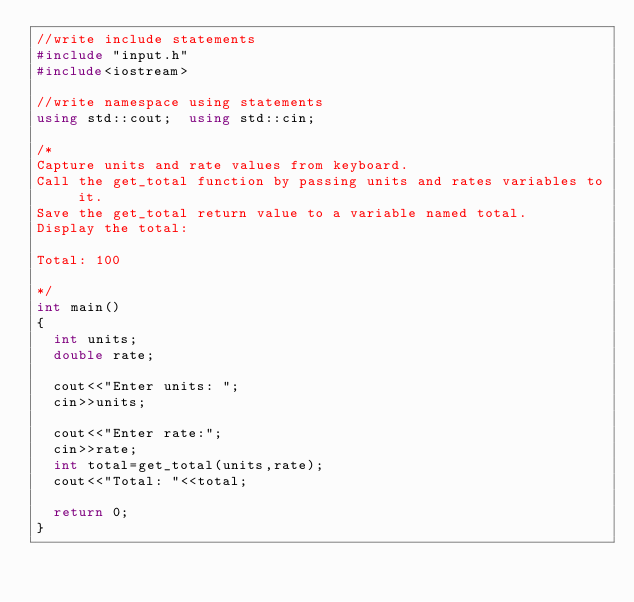<code> <loc_0><loc_0><loc_500><loc_500><_C++_>//write include statements
#include "input.h"
#include<iostream>

//write namespace using statements
using std::cout;	using std::cin;

/*
Capture units and rate values from keyboard.
Call the get_total function by passing units and rates variables to it.
Save the get_total return value to a variable named total.
Display the total:

Total: 100

*/
int main() 
{
	int units;
	double rate;

	cout<<"Enter units: ";
	cin>>units;

	cout<<"Enter rate:";
	cin>>rate;
	int total=get_total(units,rate);
	cout<<"Total: "<<total;
	
	return 0;
}</code> 